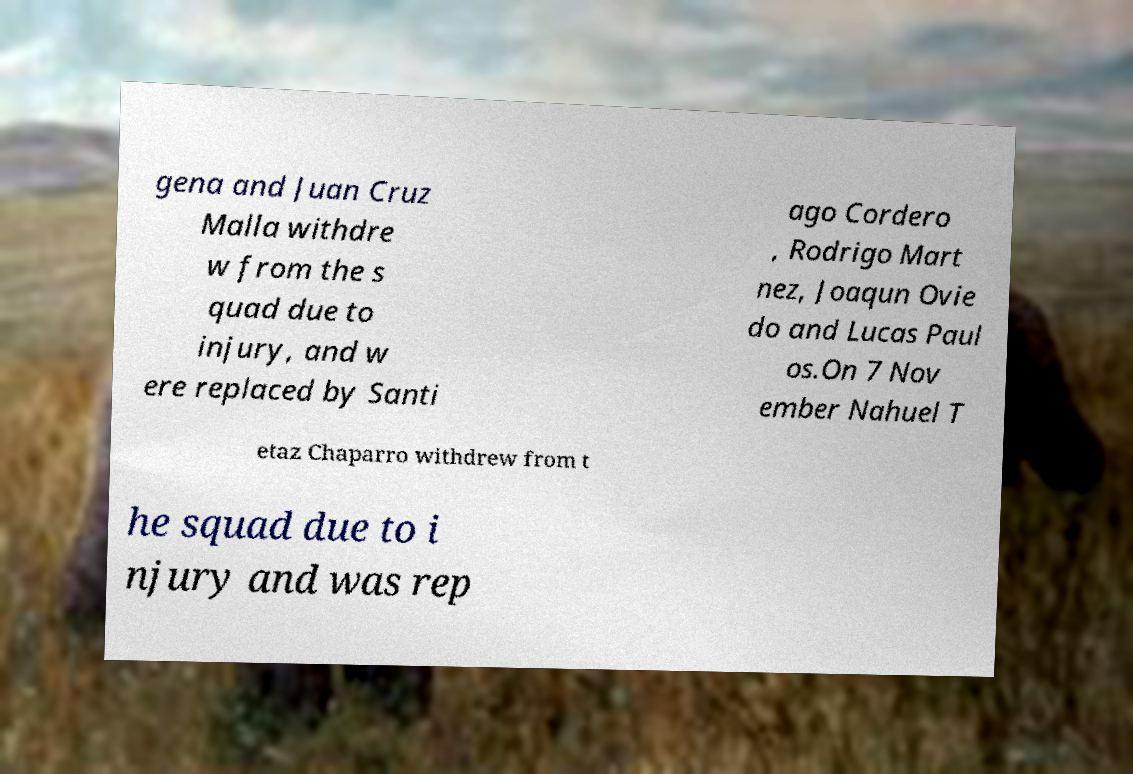What messages or text are displayed in this image? I need them in a readable, typed format. gena and Juan Cruz Malla withdre w from the s quad due to injury, and w ere replaced by Santi ago Cordero , Rodrigo Mart nez, Joaqun Ovie do and Lucas Paul os.On 7 Nov ember Nahuel T etaz Chaparro withdrew from t he squad due to i njury and was rep 